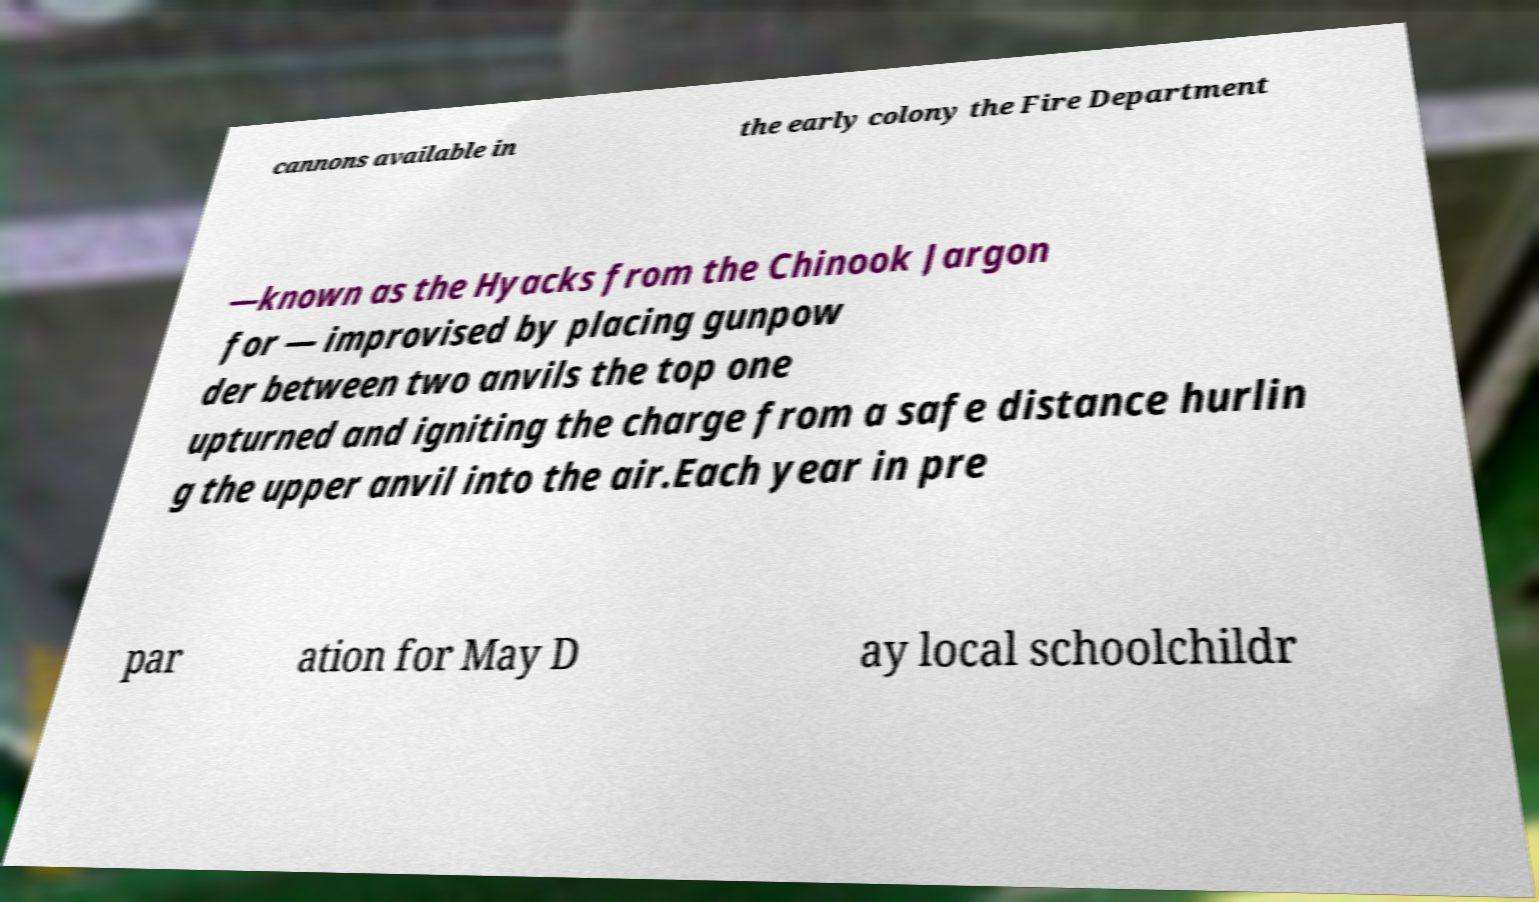Could you assist in decoding the text presented in this image and type it out clearly? cannons available in the early colony the Fire Department —known as the Hyacks from the Chinook Jargon for — improvised by placing gunpow der between two anvils the top one upturned and igniting the charge from a safe distance hurlin g the upper anvil into the air.Each year in pre par ation for May D ay local schoolchildr 